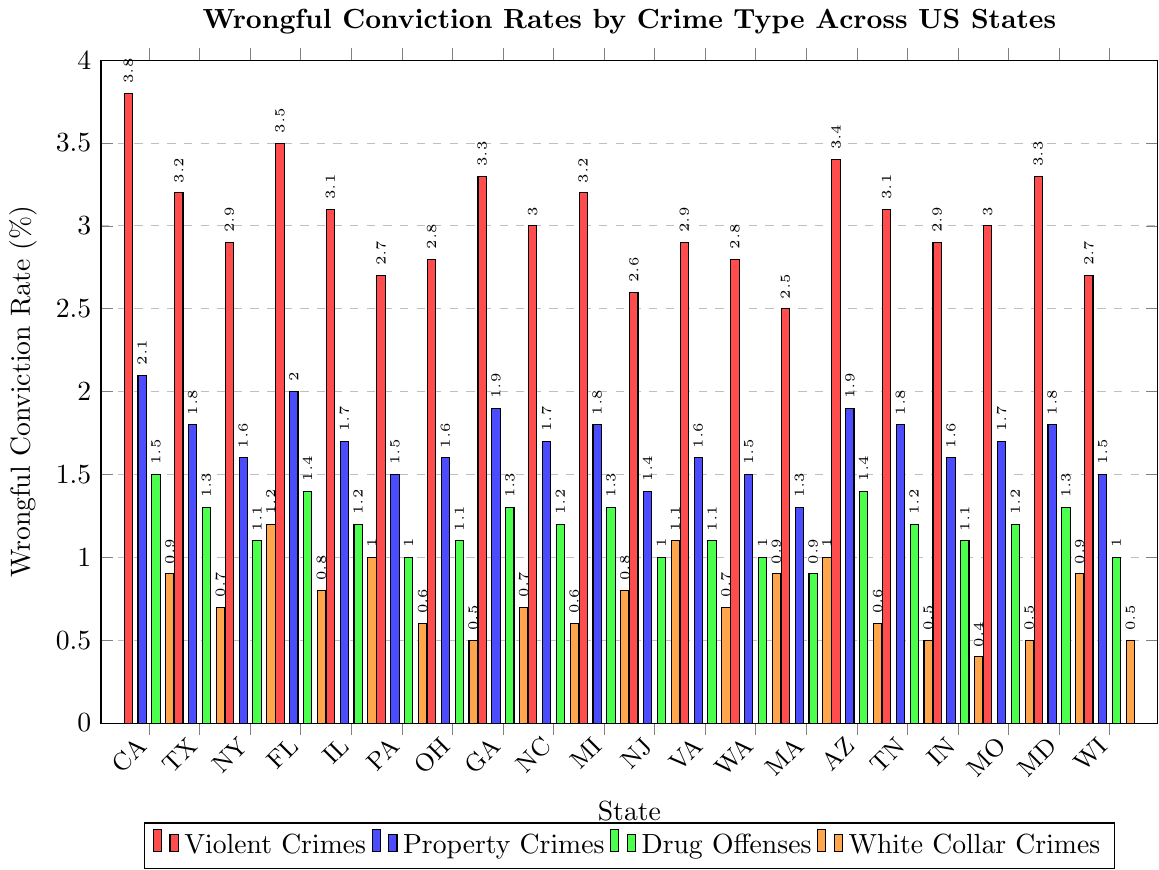Which state has the highest wrongful conviction rate for violent crimes? By visually inspecting the heights of the red bars, California's bar for violent crimes (red) is the tallest compared to other states.
Answer: California Which state has the lowest wrongful conviction rate for white-collar crimes? By looking at the heights of the orange bars, Indiana has the shortest bar for white-collar crimes.
Answer: Indiana What is the average wrongful conviction rate for drug offenses across all states? You need to add up the green bars' values for all states and then divide by the number of states: (1.5+1.3+1.1+1.4+1.2+1.0+1.1+1.3+1.2+1.3+1.0+1.1+1.0+0.9+1.4+1.2+1.1+1.2+1.3+1.0)/20 = 1.18
Answer: 1.18 Which state has a lower wrongful conviction rate for property crimes, New York or Pennsylvania? Compare the heights of the blue bars for New York and Pennsylvania. New York's blue bar is slightly taller than Pennsylvania's.
Answer: Pennsylvania What is the difference in wrongful conviction rates for violent crimes between Texas and Georgia? Subtract Texas's rate (3.2) from Georgia's rate (3.3): 3.3 - 3.2 = 0.1
Answer: 0.1 How many states have a wrongful conviction rate for property crimes that is less than or equal to 1.5%? Count the states with blue bars at or below 1.5%. These states are Pennsylvania, New Jersey, Washington, Massachusetts, and Wisconsin (5 states).
Answer: 5 Which state has the highest discrepancy between wrongful conviction rates for violent crimes and white-collar crimes? Look for the state with the largest difference between the red bar and the orange bar. California has the greatest difference with 3.8% for violent crimes and 0.9% for white-collar crimes. The discrepancy is 2.9%.
Answer: California What is the combined wrongful conviction rate for property crimes and white-collar crimes in Virginia? Add the rates for Virginia from the blue bar and the orange bar: 1.6 + 0.7 = 2.3
Answer: 2.3 Which crime category has the most consistent rates across all states? Visually compare the uniformity of the bars for each crime category. Drug offenses (green bars) seem to have the most consistent heights across states.
Answer: Drug Offenses In which state are wrongful conviction rates for violent crimes and property crimes equal? By comparing the heights of the red and blue bars, no state has equal rates for these two categories.
Answer: None 